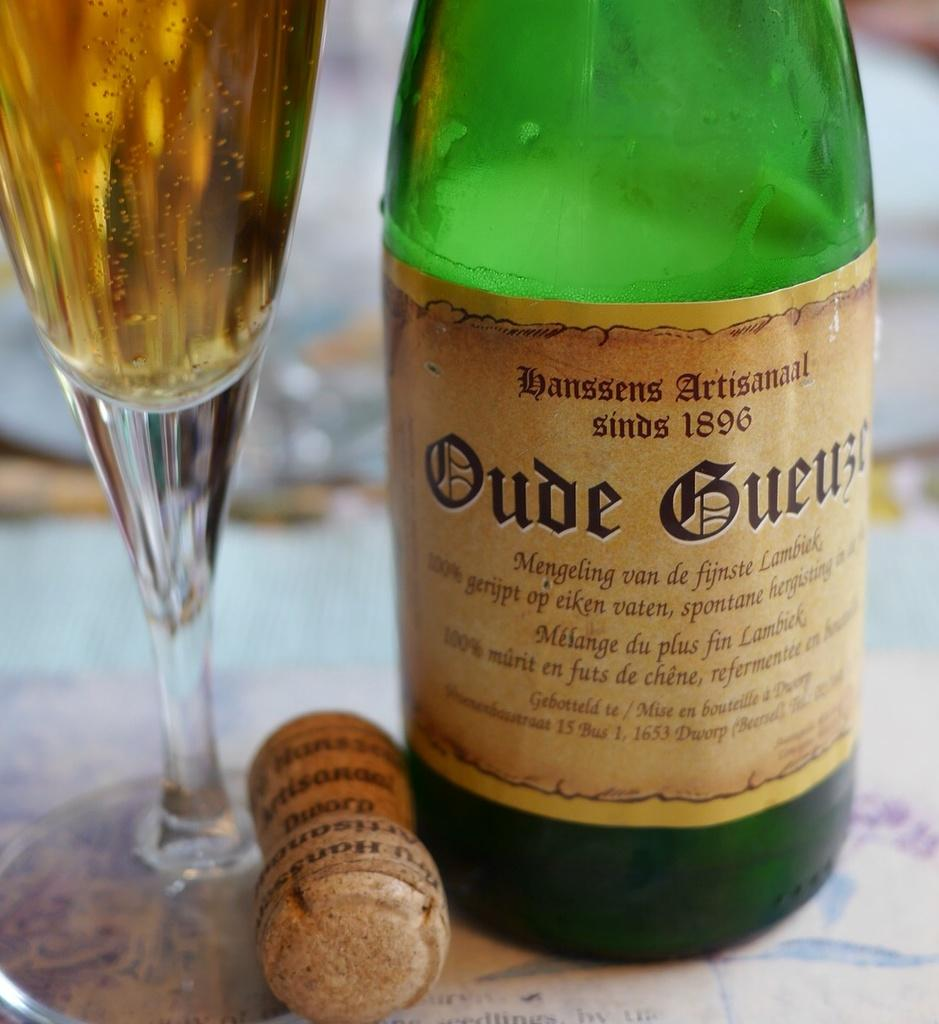<image>
Render a clear and concise summary of the photo. A bottle of wine says that the company has been in business since 1896. 